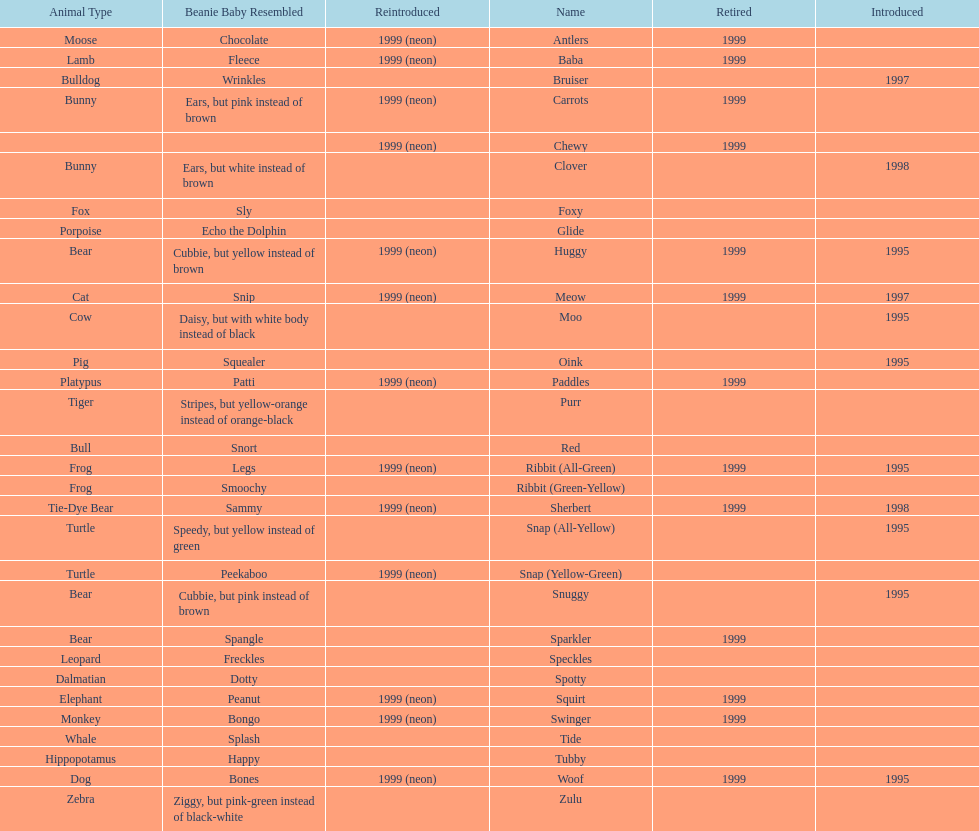What is the count of monkey pillow pals? 1. 